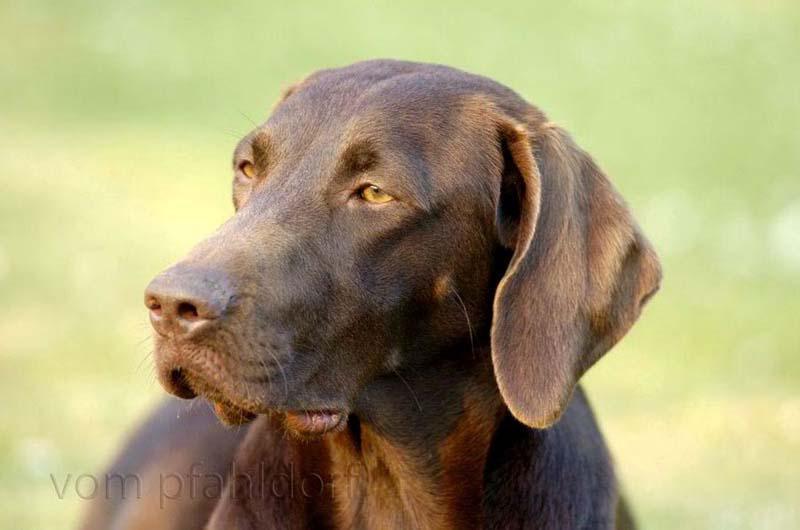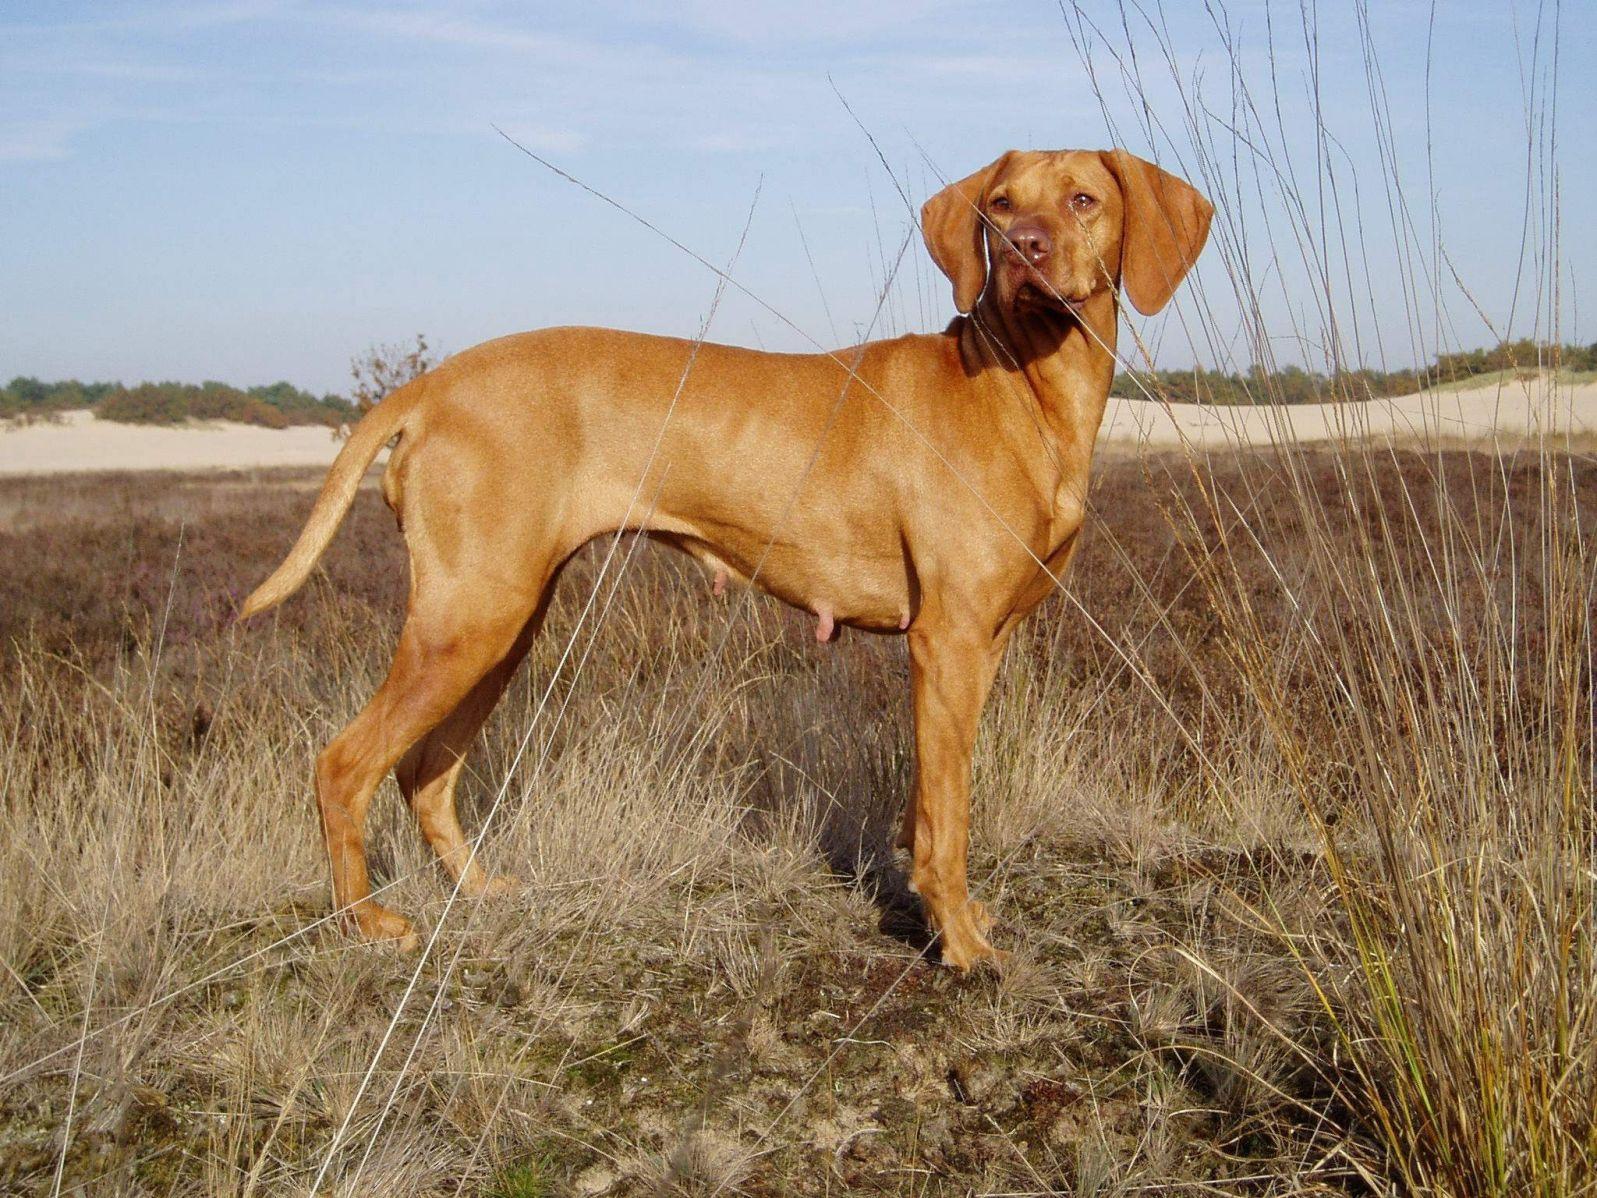The first image is the image on the left, the second image is the image on the right. Evaluate the accuracy of this statement regarding the images: "The dog on the left is gazing leftward, and the dog on the right stands in profile with its body turned rightward.". Is it true? Answer yes or no. Yes. The first image is the image on the left, the second image is the image on the right. Considering the images on both sides, is "At least one dog is sitting." valid? Answer yes or no. No. 